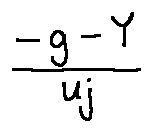Convert formula to latex. <formula><loc_0><loc_0><loc_500><loc_500>\frac { - g - Y } { u j }</formula> 